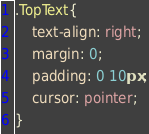<code> <loc_0><loc_0><loc_500><loc_500><_CSS_>.TopText{
    text-align: right;
    margin: 0;
    padding: 0 10px;
    cursor: pointer;
}</code> 